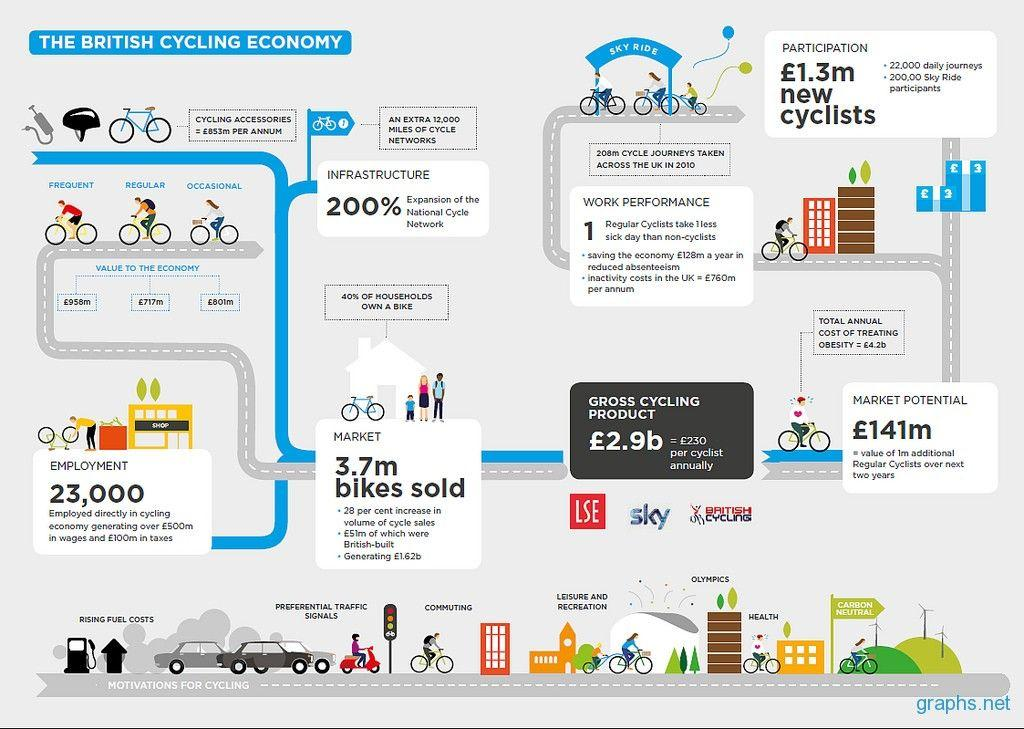Mention a couple of crucial points in this snapshot. It is estimated that approximately 23,000 people are employed in the cycling economy. The study found that regular cyclists had better performance at work than non-cyclists. 